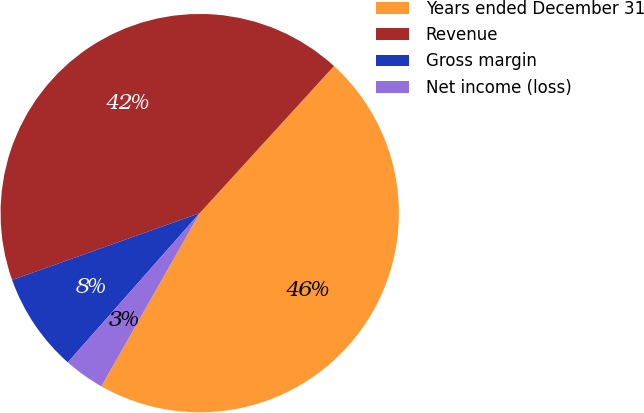Convert chart to OTSL. <chart><loc_0><loc_0><loc_500><loc_500><pie_chart><fcel>Years ended December 31<fcel>Revenue<fcel>Gross margin<fcel>Net income (loss)<nl><fcel>46.45%<fcel>42.23%<fcel>8.03%<fcel>3.3%<nl></chart> 